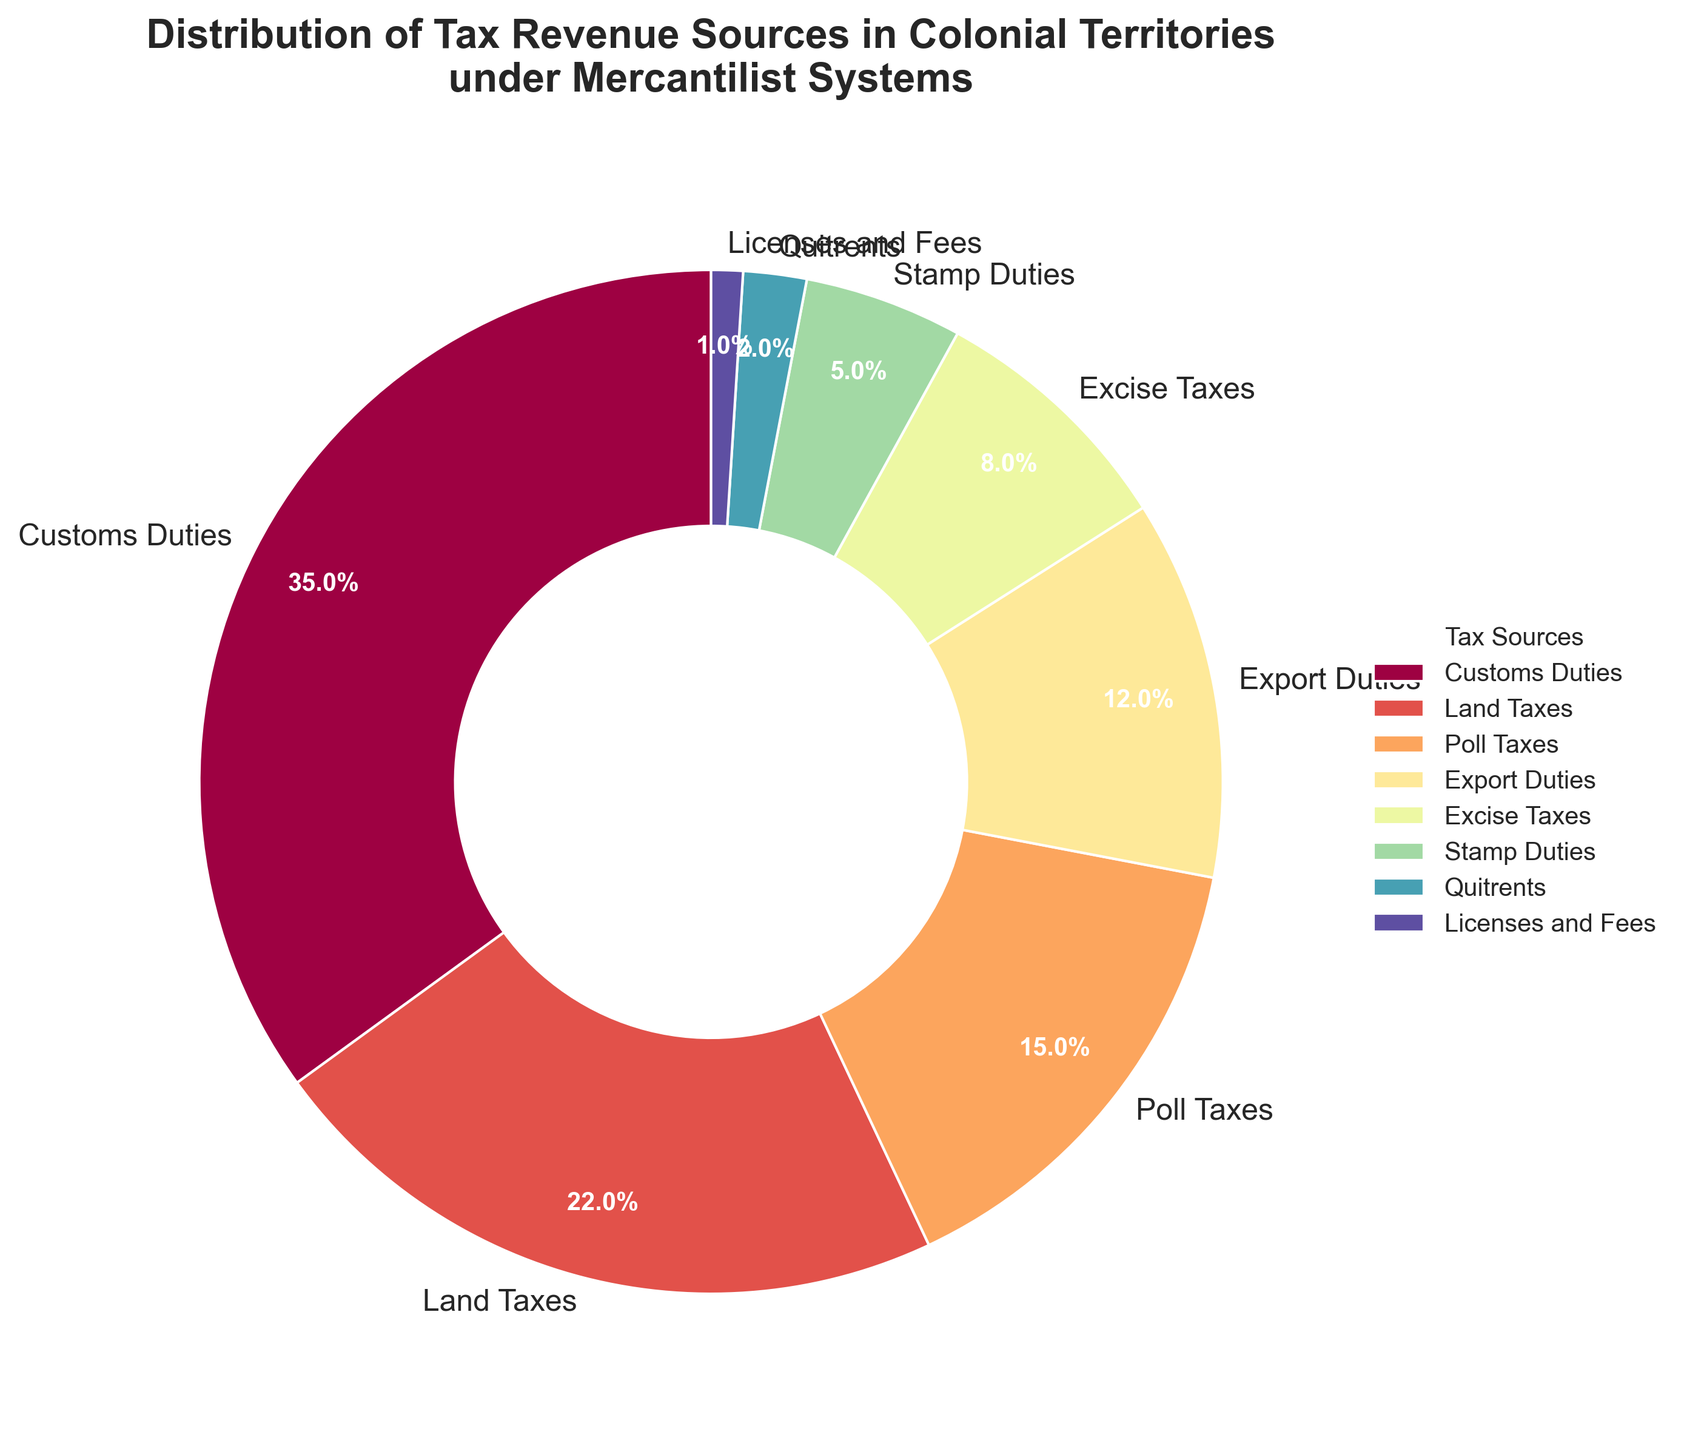What's the largest tax revenue source depicted in the pie chart? The pie chart shows that Customs Duties is the largest segment, occupying 35% of the entire chart.
Answer: Customs Duties What is the combined percentage of Poll Taxes and Export Duties? The pie chart indicates Poll Taxes constitute 15% and Export Duties account for 12%. Adding them together, 15% + 12% = 27%.
Answer: 27% How does the percentage of Excise Taxes compare to that of Stamp Duties? From the pie chart, Excise Taxes contribute 8% to the tax revenue, while Stamp Duties contribute 5%. Compared to Stamp Duties, Excise Taxes constitute a higher percentage.
Answer: Excise Taxes are greater Which tax revenue sources combined constitute less than 10%? The pie chart shows Stamp Duties at 5%, Quitrents at 2%, and Licenses and Fees at 1%. Summing these percentages, 5% + 2% + 1% = 8%, qualifying as less than 10%.
Answer: Stamp Duties, Quitrents, Licenses and Fees What is the visual distinction between Customs Duties and Land Taxes? Customs Duties, shown as the largest and most prominent segment in the pie chart at 35%, are visually distinct with a larger area compared to Land Taxes, which occupy 22% of the chart.
Answer: Customs Duties segment is larger than Land Taxes segment Which tax revenue source accounts for the smallest percentage? According to the pie chart, Licenses and Fees constitute the smallest percentage at 1%.
Answer: Licenses and Fees What is the difference in percentage between Land Taxes and Poll Taxes? The pie chart depicts Land Taxes at 22% and Poll Taxes at 15%. The difference can be calculated as 22% - 15% = 7%.
Answer: 7% How do the combined contributions of Excise Taxes and Quitrents compare to the contributions of Export Duties? Excise Taxes contribute 8% and Quitrents contribute 2%, together summing up to 8% + 2% = 10%. Export Duties alone contribute 12%, which is higher.
Answer: Export Duties are higher What percentage of the tax revenue is contributed by non-duty taxes (excluding Customs and Export Duties)? Excluding Customs Duties (35%) and Export Duties (12%), the sum of the remaining taxes is: 22% + 15% + 8% + 5% + 2% + 1% = 53%.
Answer: 53% What tax source has the second highest share, and what is its percentage? The pie chart shows the second largest segment is Land Taxes, which contribute 22%.
Answer: Land Taxes, 22% 